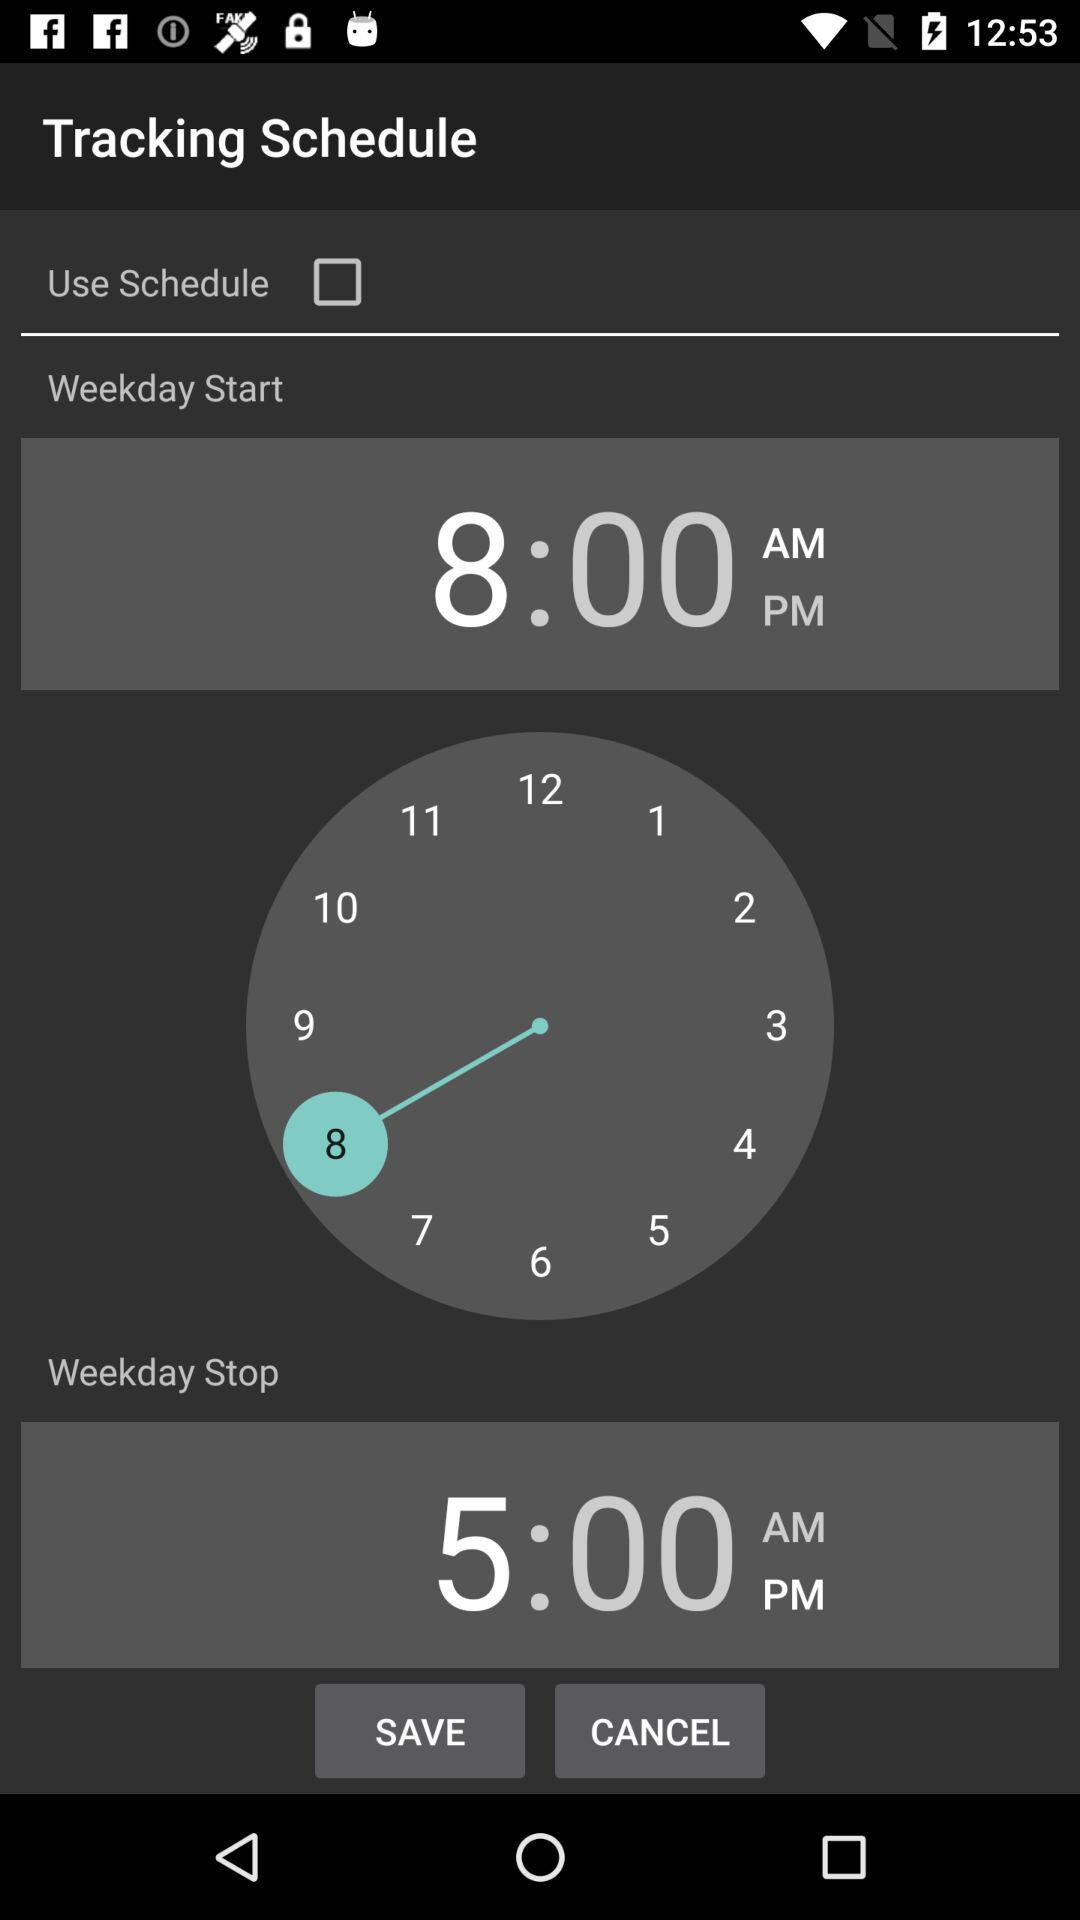What starts at 8.00 AM? At 8 AM, the weekday starts. 